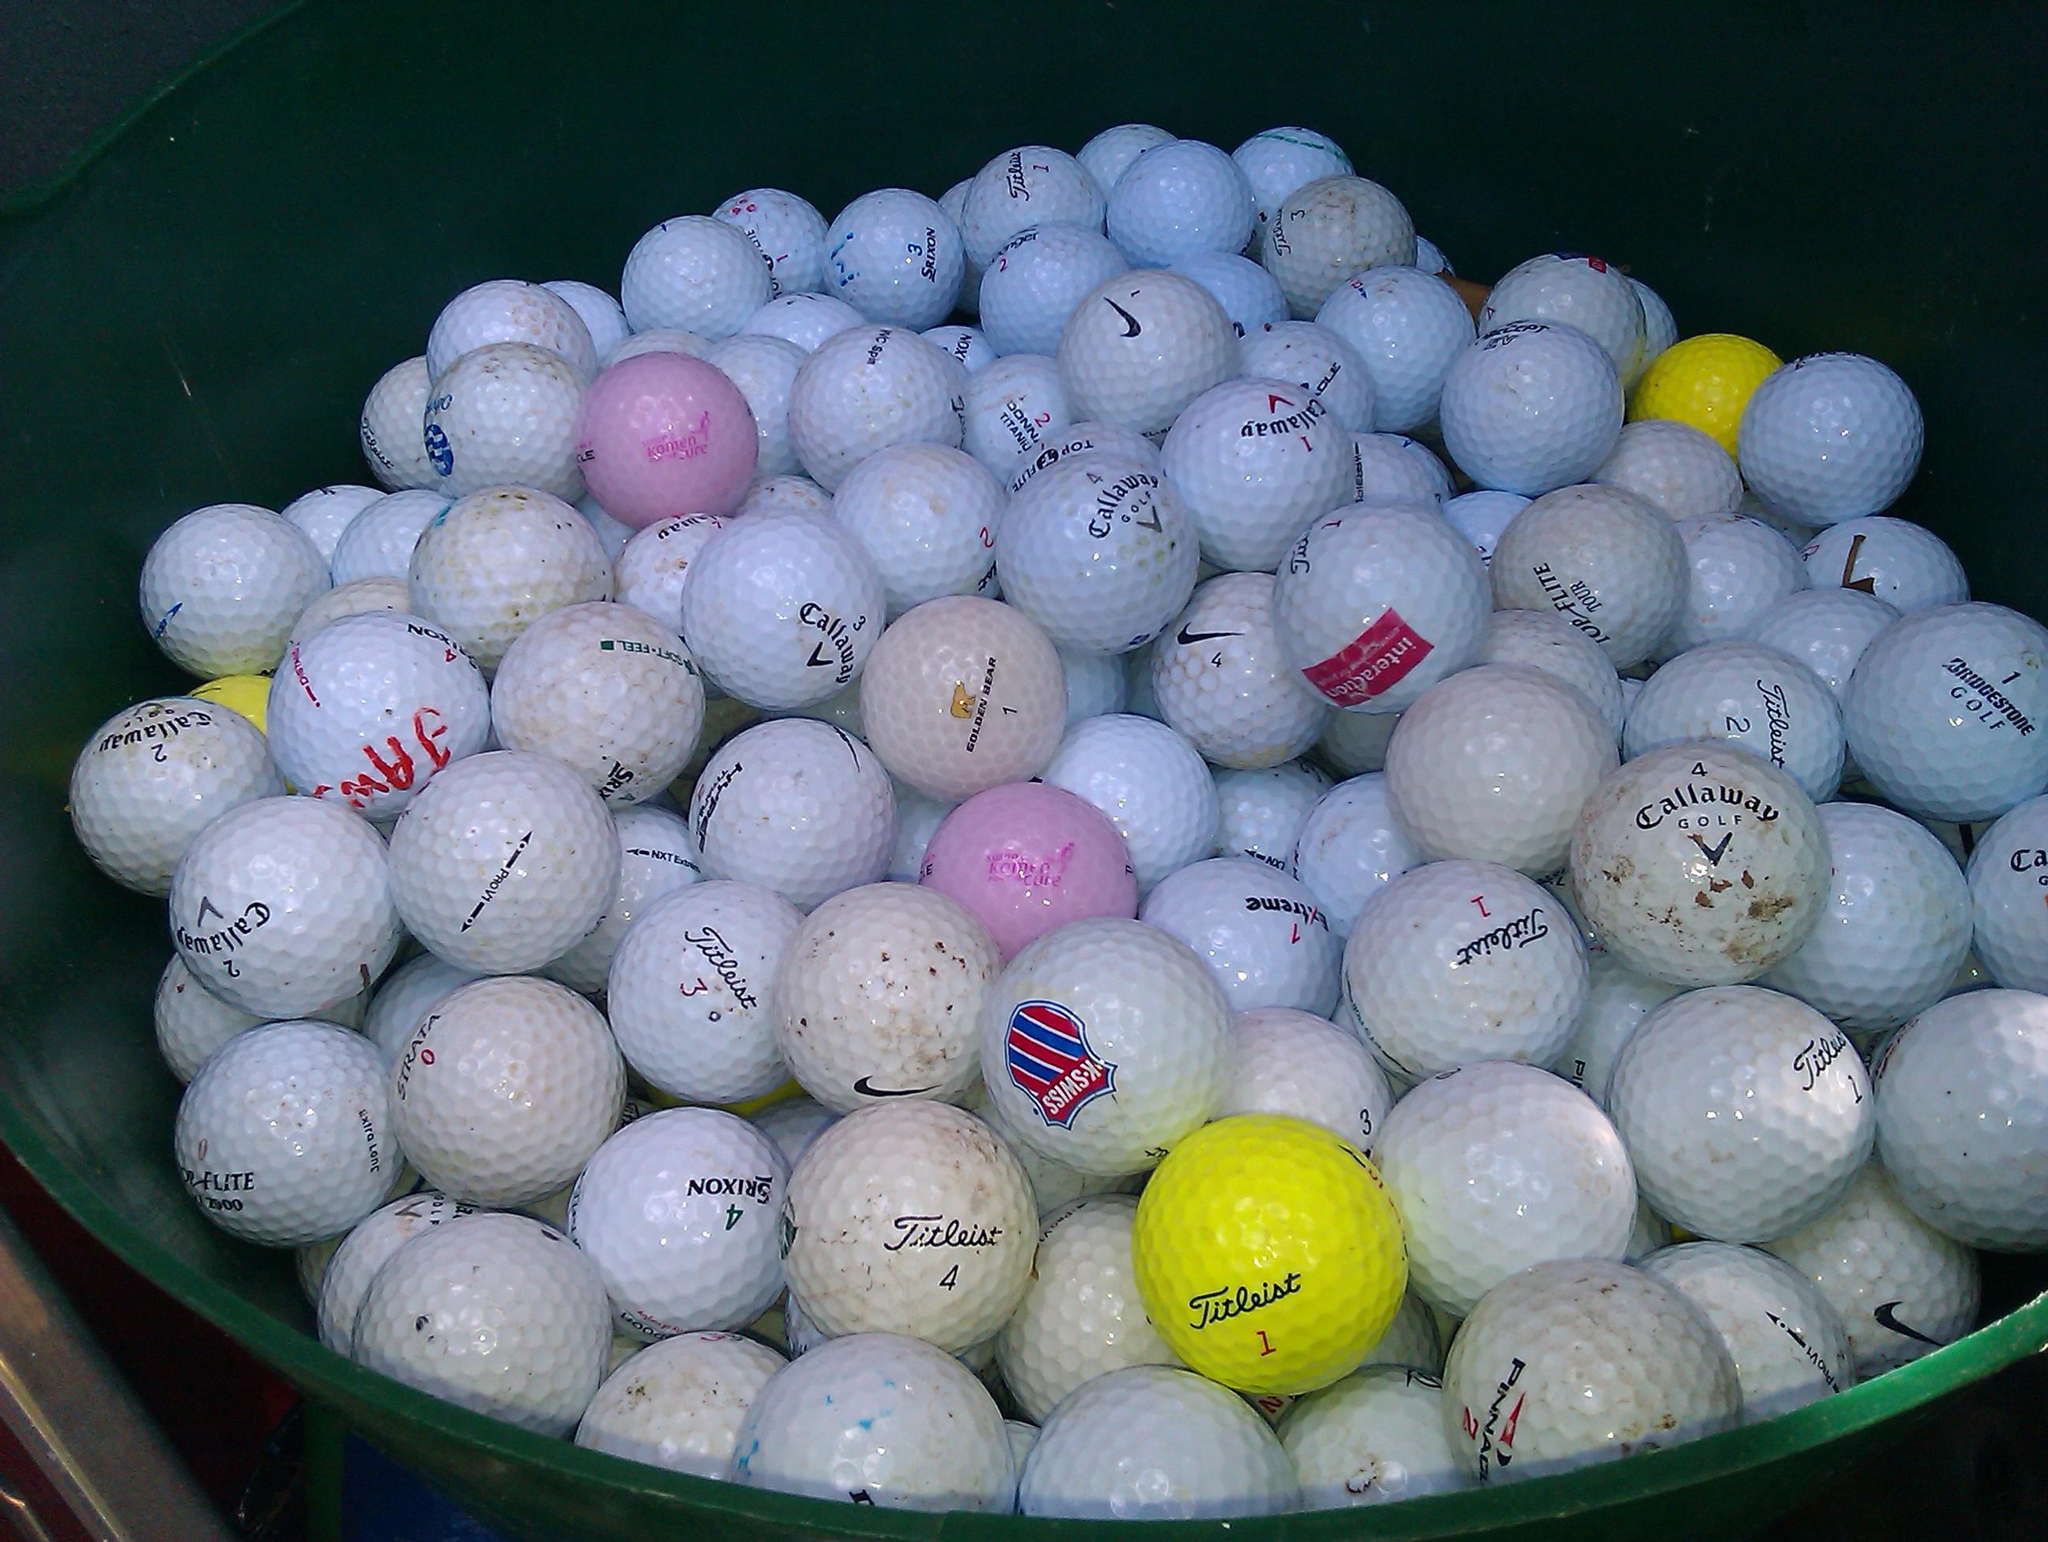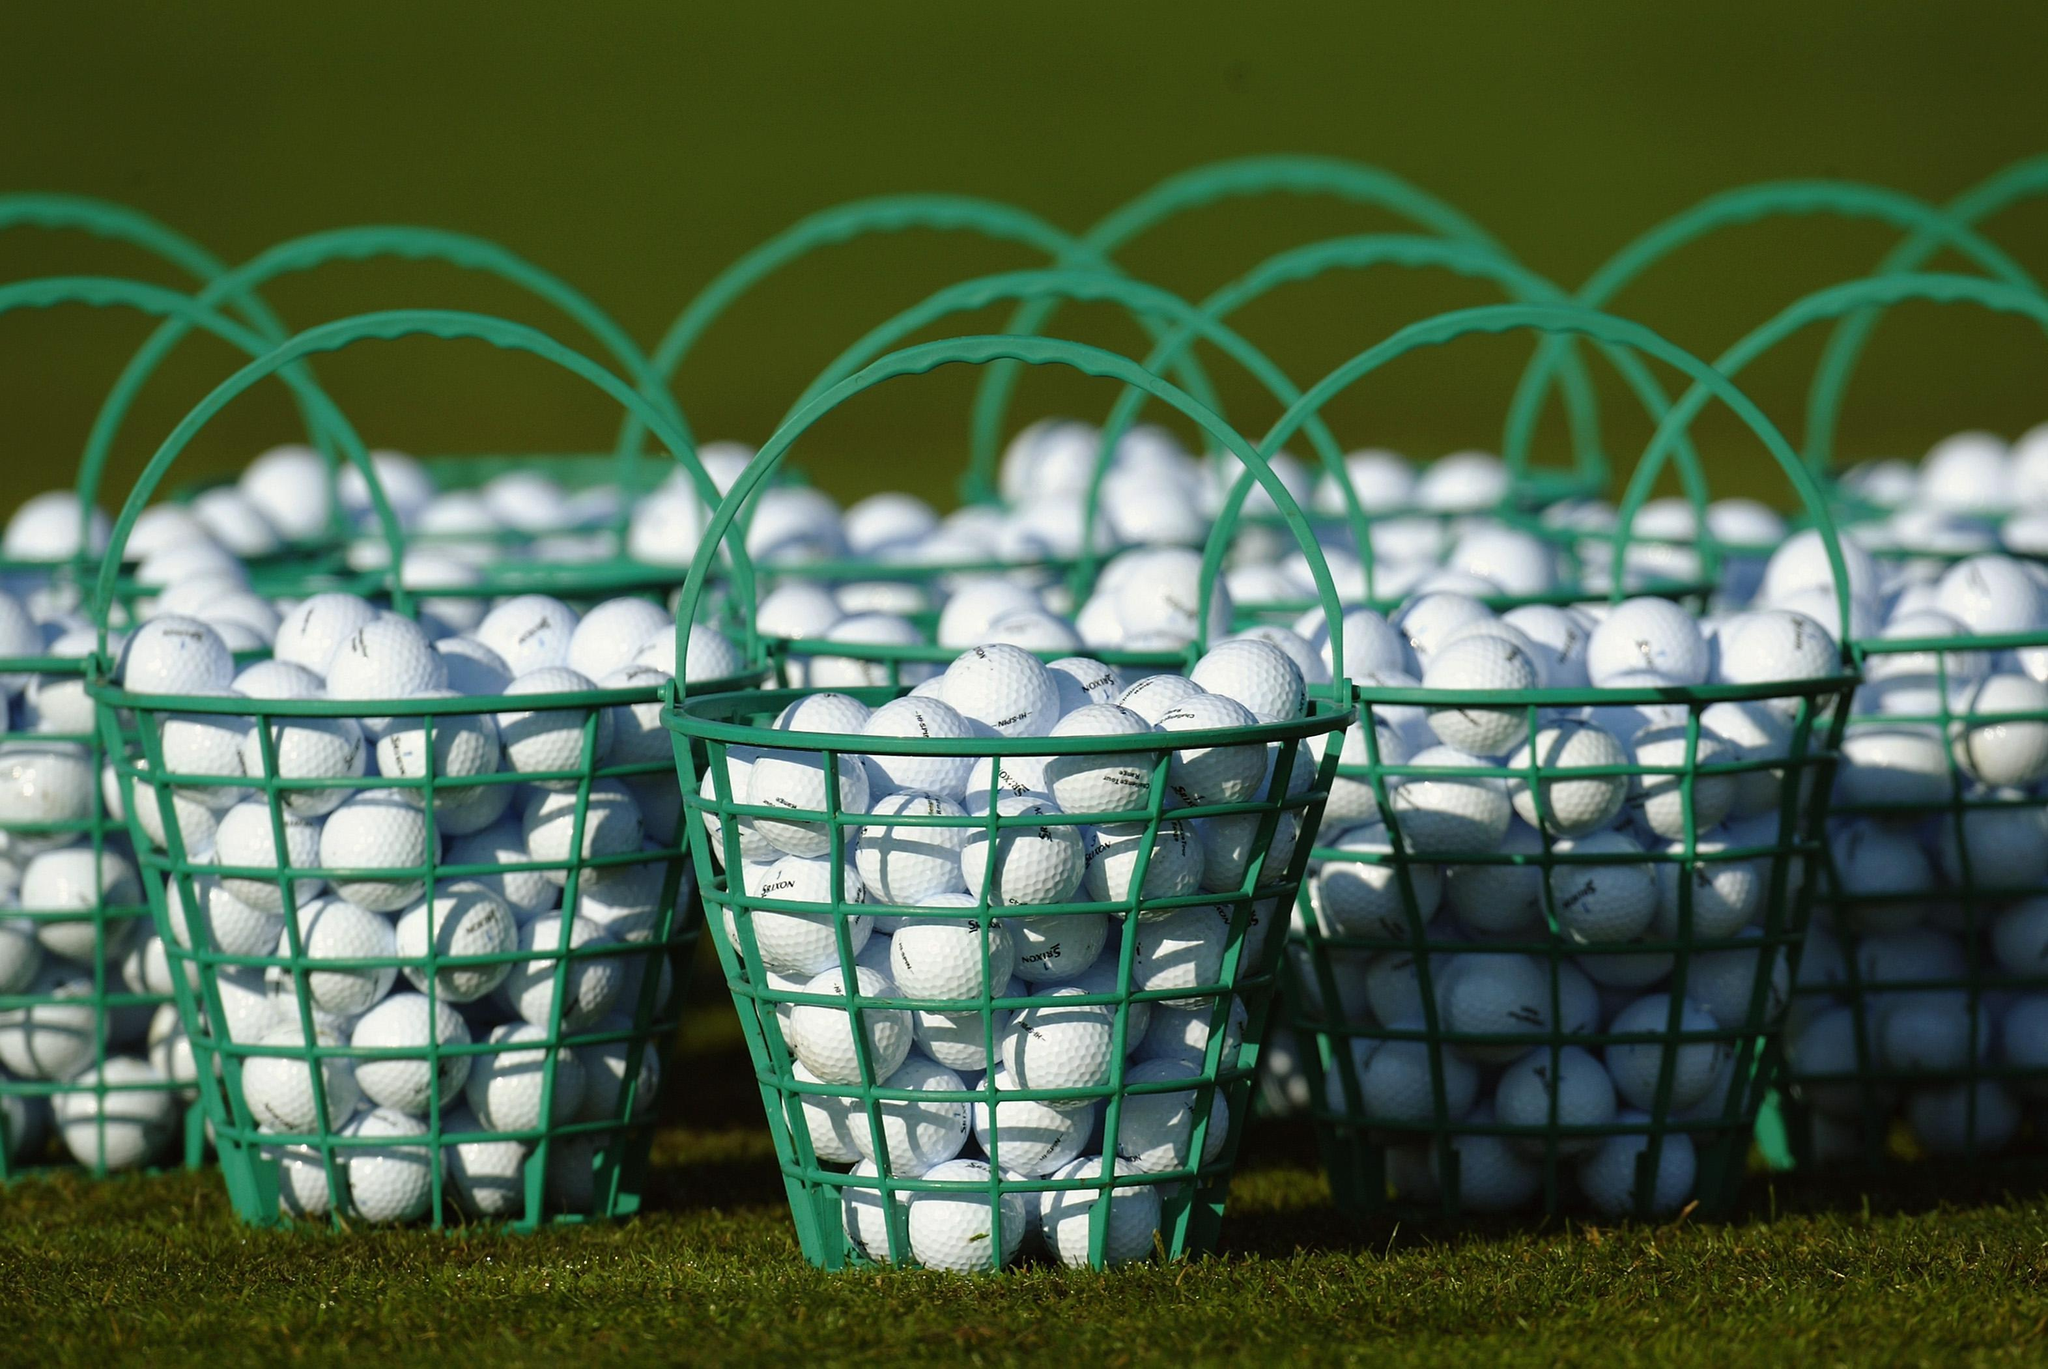The first image is the image on the left, the second image is the image on the right. Considering the images on both sides, is "At least one pink golf ball can be seen in a large pile of mostly white golf balls in one image." valid? Answer yes or no. Yes. The first image is the image on the left, the second image is the image on the right. For the images shown, is this caption "At least one image shows white golf balls in a mesh-type green basket." true? Answer yes or no. Yes. 